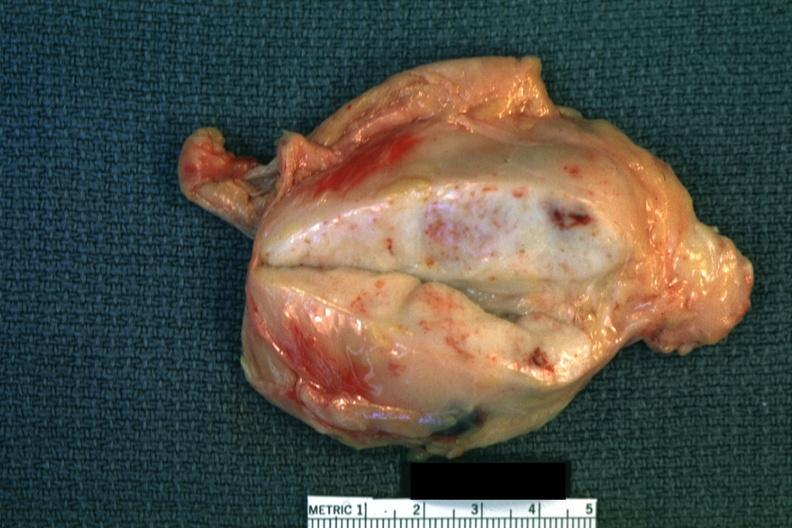what is present?
Answer the question using a single word or phrase. Hodgkins disease 